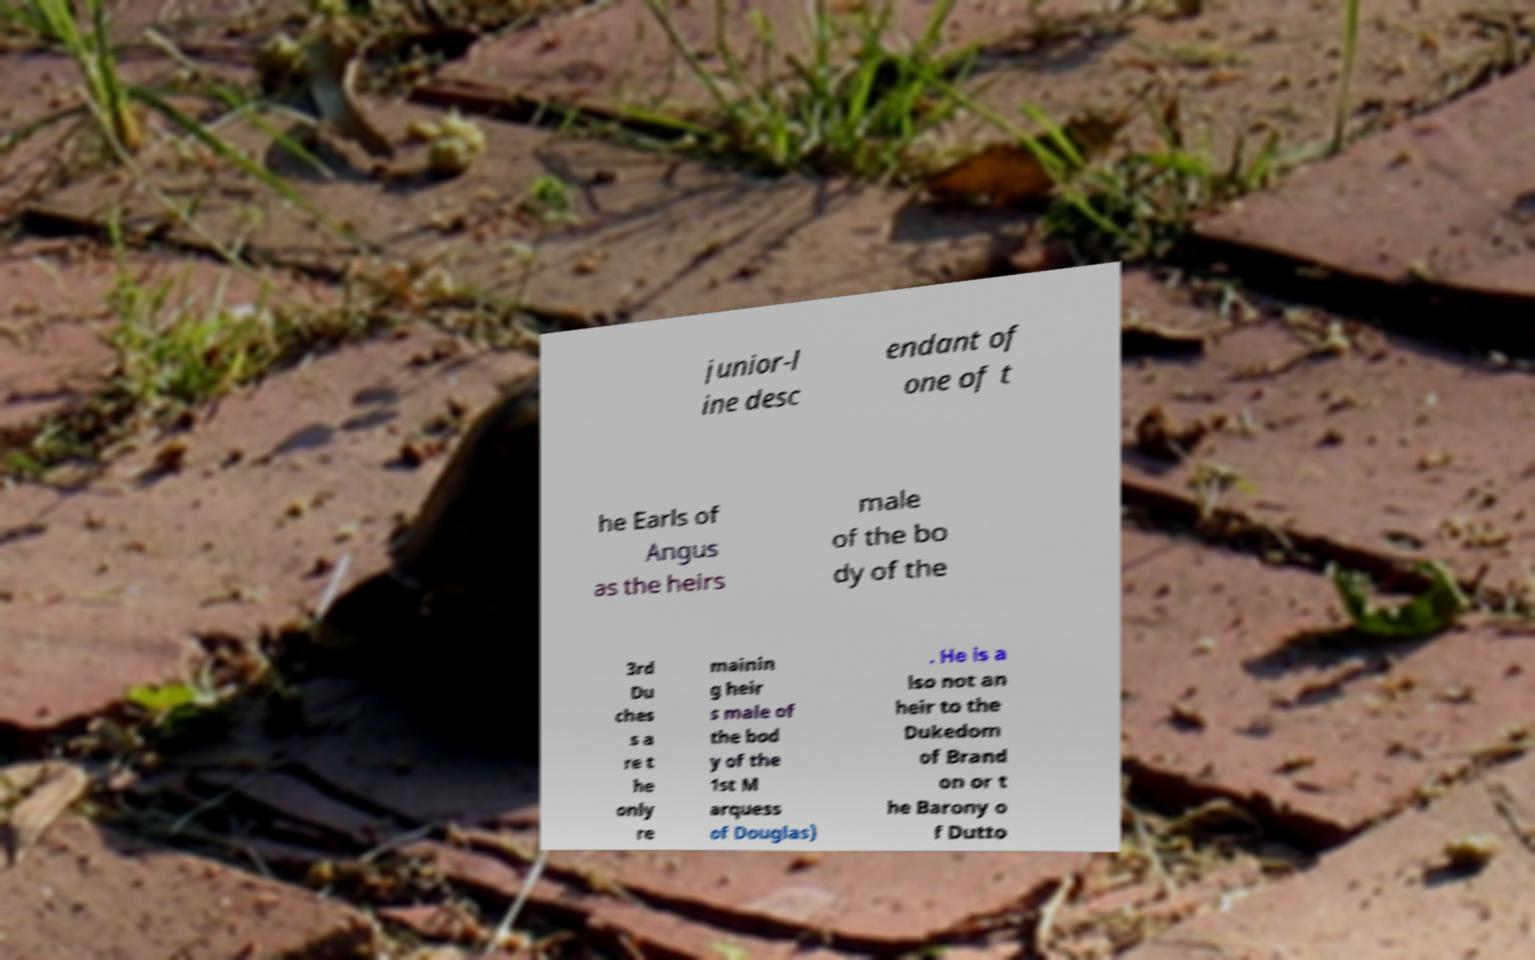There's text embedded in this image that I need extracted. Can you transcribe it verbatim? junior-l ine desc endant of one of t he Earls of Angus as the heirs male of the bo dy of the 3rd Du ches s a re t he only re mainin g heir s male of the bod y of the 1st M arquess of Douglas) . He is a lso not an heir to the Dukedom of Brand on or t he Barony o f Dutto 